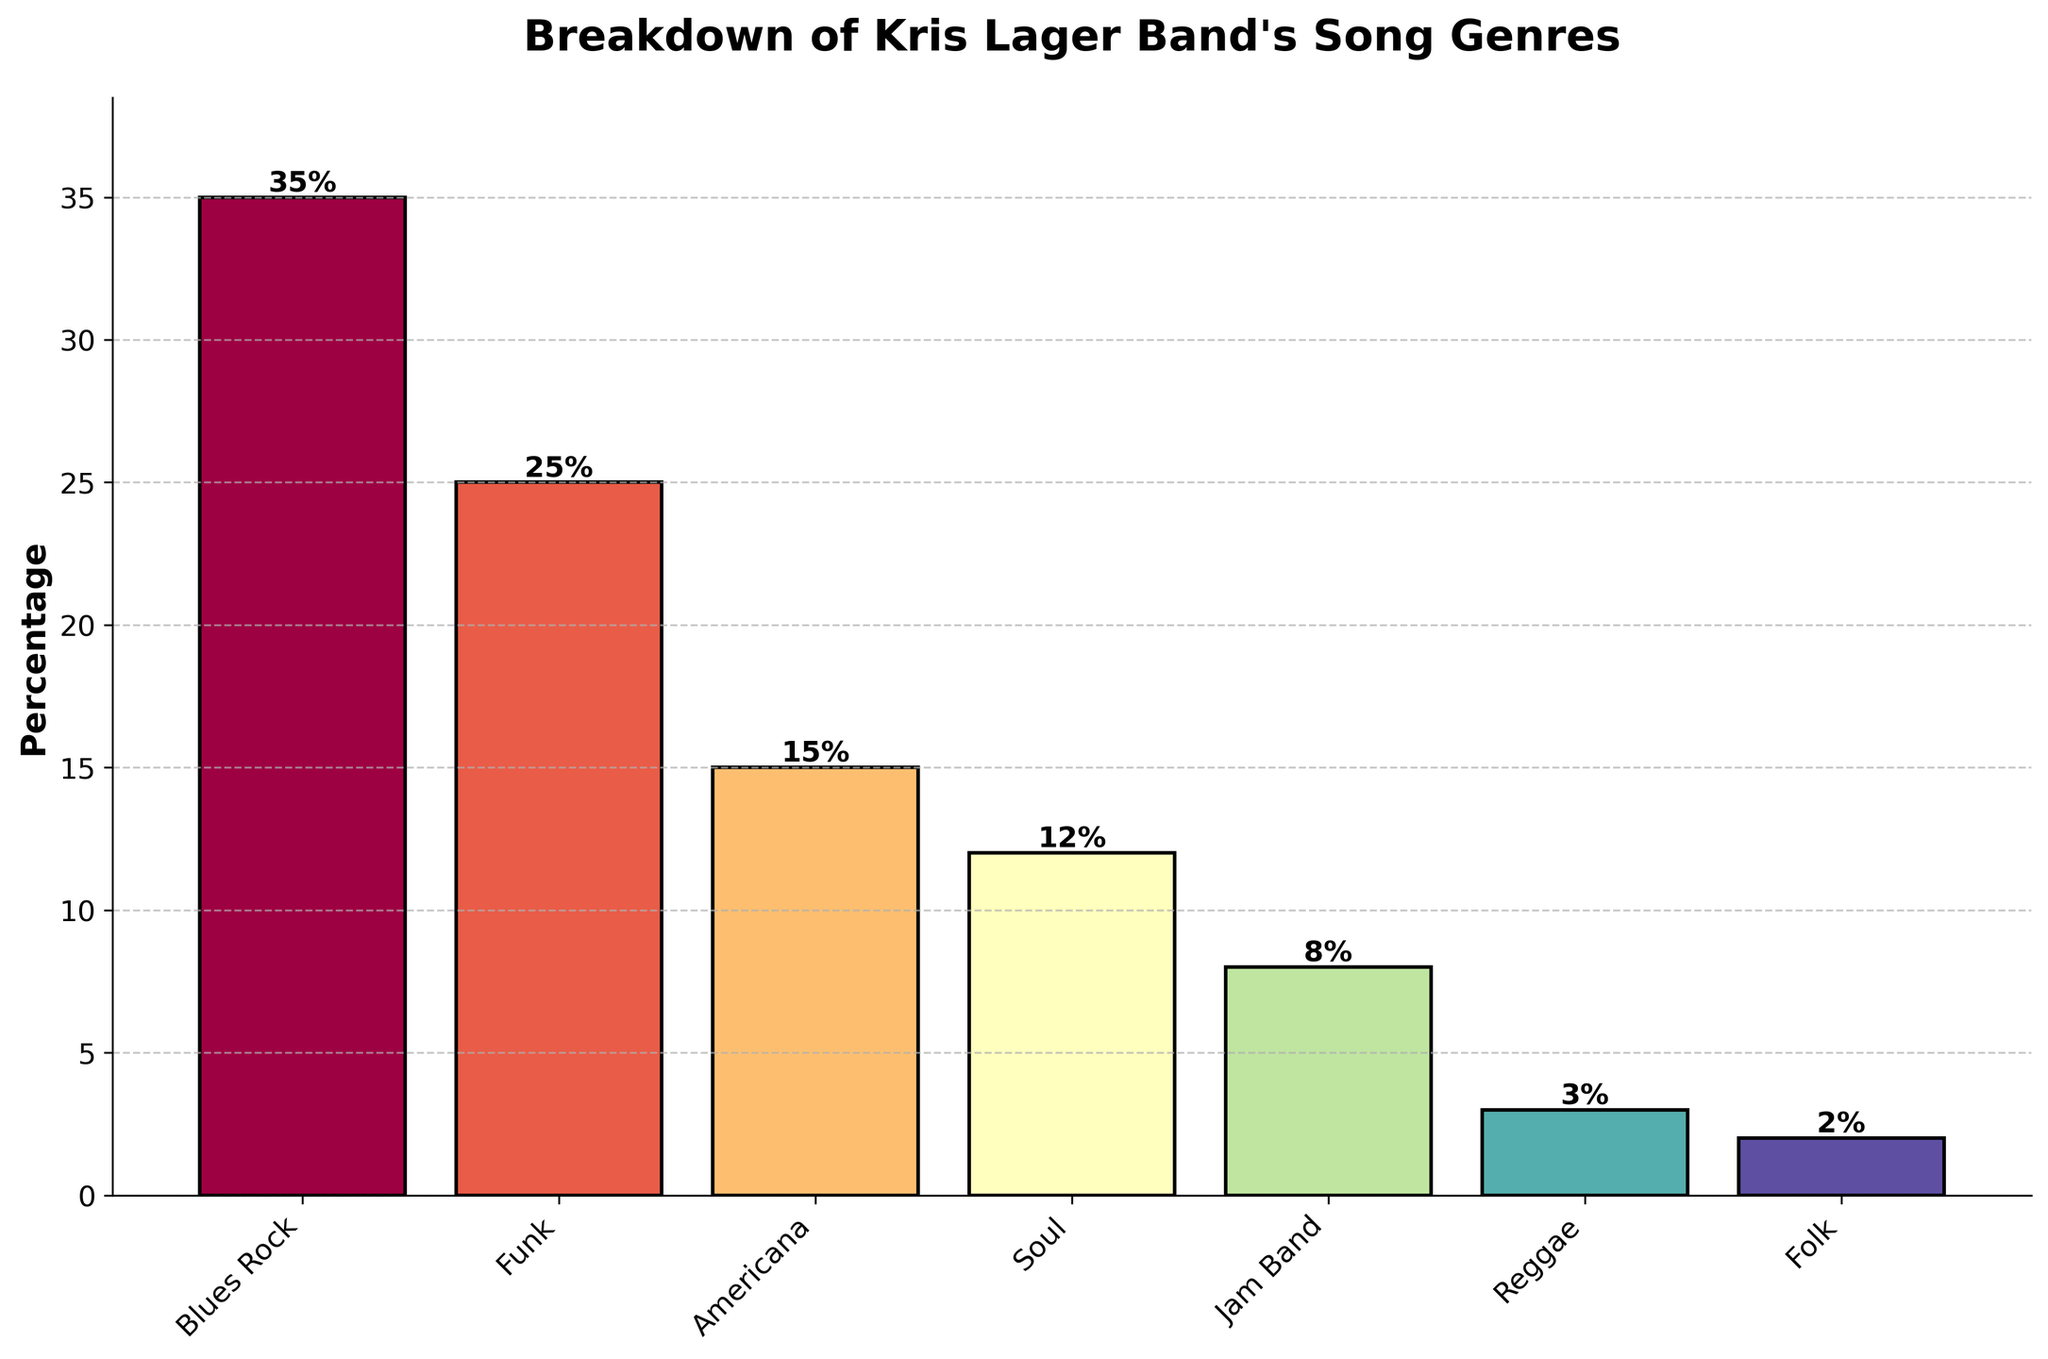Which genre has the highest percentage? The highest bar represents the genre with the highest percentage. The tallest bar is labeled "Blues Rock" at 35%.
Answer: Blues Rock Which genre has the lowest percentage? The lowest bar represents the genre with the lowest percentage. The shortest bar is labeled "Folk" at 2%.
Answer: Folk How much higher is the percentage of Blues Rock compared to Funk? Subtract the percentage of Funk from that of Blues Rock: 35% - 25%.
Answer: 10% What is the combined percentage of Funk and Soul genres? Add the percentages of Funk and Soul: 25% + 12%.
Answer: 37% How many genres have percentages above 10%? Identify bars with heights above 10%. They are Blues Rock, Funk, Americana, and Soul. Count them up: 4 genres.
Answer: 4 How does the percentage of Americana compare to that of Jam Band? Compare the heights of the Americana and Jam Band bars: Americana (15%) is higher than Jam Band (8%).
Answer: Americana is higher What's the difference in percentage between Soul and Jam Band genres? Subtract the percentage of Jam Band from that of Soul: 12% - 8%.
Answer: 4% What is the average percentage of the depicted genres? Sum up all the genre percentages and divide by the number of genres: (35% + 25% + 15% + 12% + 8% + 3% + 2%) / 7.
Answer: 14.29% What color represents the Reggae genre? Identify the bar labeled "Reggae" and describe its color from the visualization. In the Spectral colormap, Reggae is towards the cooler end, appearing in lightish blue.
Answer: Lightish Blue Which genre is represented with a bar height closest to the 10% mark? Compare bars to the 10% level. Jam Band at 8% is closest.
Answer: Jam Band (8%) 